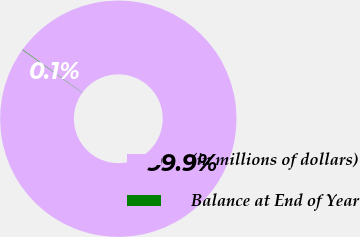Convert chart to OTSL. <chart><loc_0><loc_0><loc_500><loc_500><pie_chart><fcel>(in millions of dollars)<fcel>Balance at End of Year<nl><fcel>99.93%<fcel>0.07%<nl></chart> 